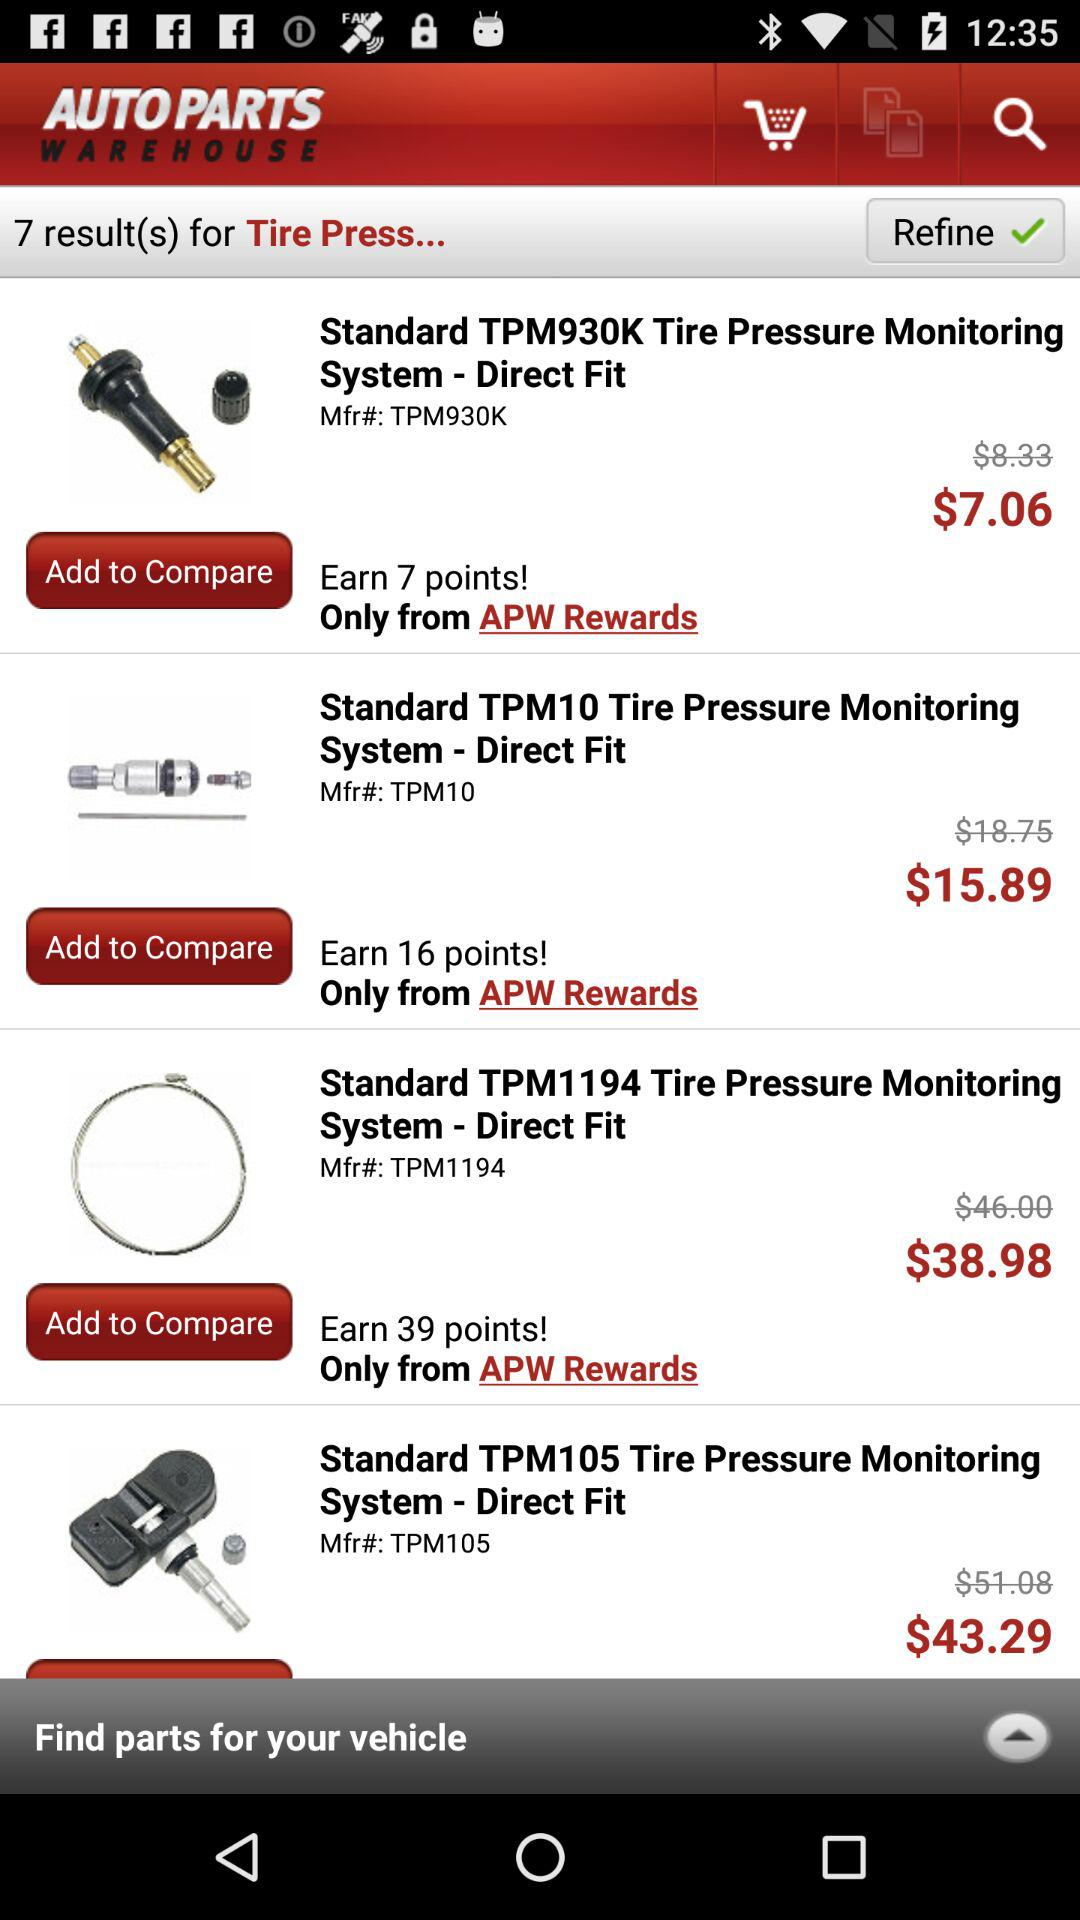What is the price of the standard TPM930K? The price of the standard TPM930K is $7.06. 